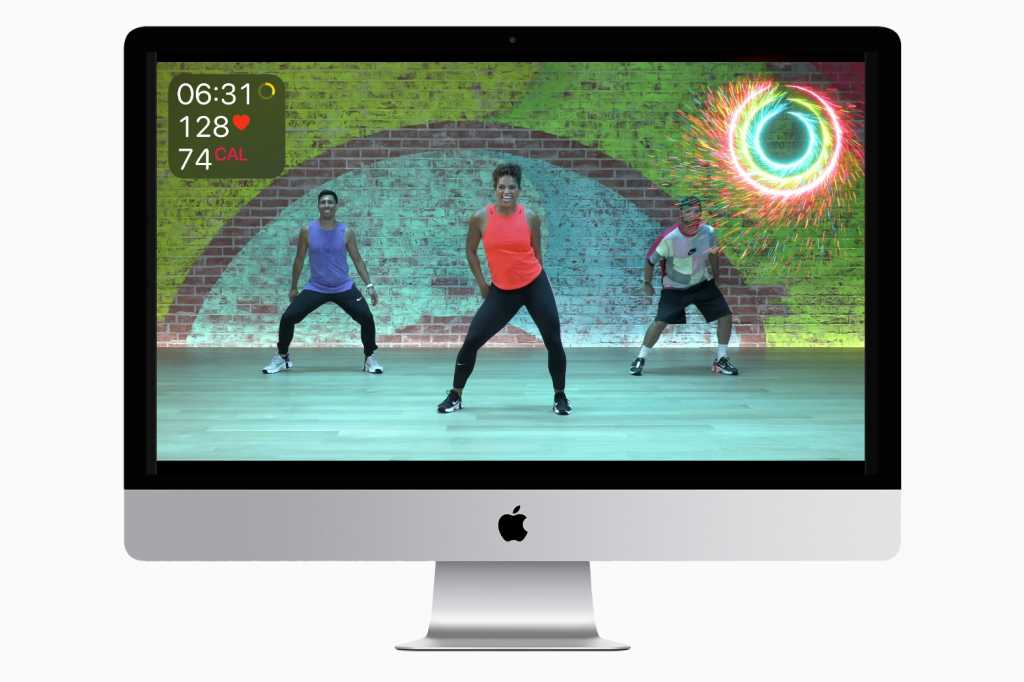How does the colorful environment affect the workout experience? The colorful environment likely enhances the workout experience by creating a more stimulating and enjoyable atmosphere. It can boost mood, reduce feelings of fatigue, and increase motivation, making the workout session feel less monotonous and more engaging. Bright and vibrant colors can energize users, encouraging them to put in their best effort and make the exercise feel like a fun activity rather than a chore. Can the software be used by individuals at different fitness levels? Absolutely. The software can be designed to accommodate users at various fitness levels by offering adjustable workout intensities and personalized recommendations based on the user's fitness data. This inclusivity ensures that beginners, intermediates, and advanced users can all find suitable workout routines that match their capabilities and help them progress at their own pace. What if the software had a virtual reality feature? How could that change the user experience? If the software incorporated a virtual reality (VR) feature, it could revolutionize the user experience by immersing individuals in dynamic, interactive workout environments. Users could feel like they’re running through exotic landscapes, attending live fitness classes, or even participating in gamified workout sessions, enhancing engagement and motivation. VR could also provide real-time, 360-degree feedback on form and technique, creating a highly interactive and personalized fitness journey that can adapt to users' movements and responses. How could this software integrate social features to enhance user engagement? The software could integrate social features like live classes, where users can interact with peers and instructors in real-time, fostering a sense of community. Features such as leaderboards, fitness challenges, and progress sharing on social media can create friendly competition and mutual encouragement. Additionally, users could form or join interest-based fitness groups, participate in group challenges, and share their achievements, creating a supportive and motivating social network. 